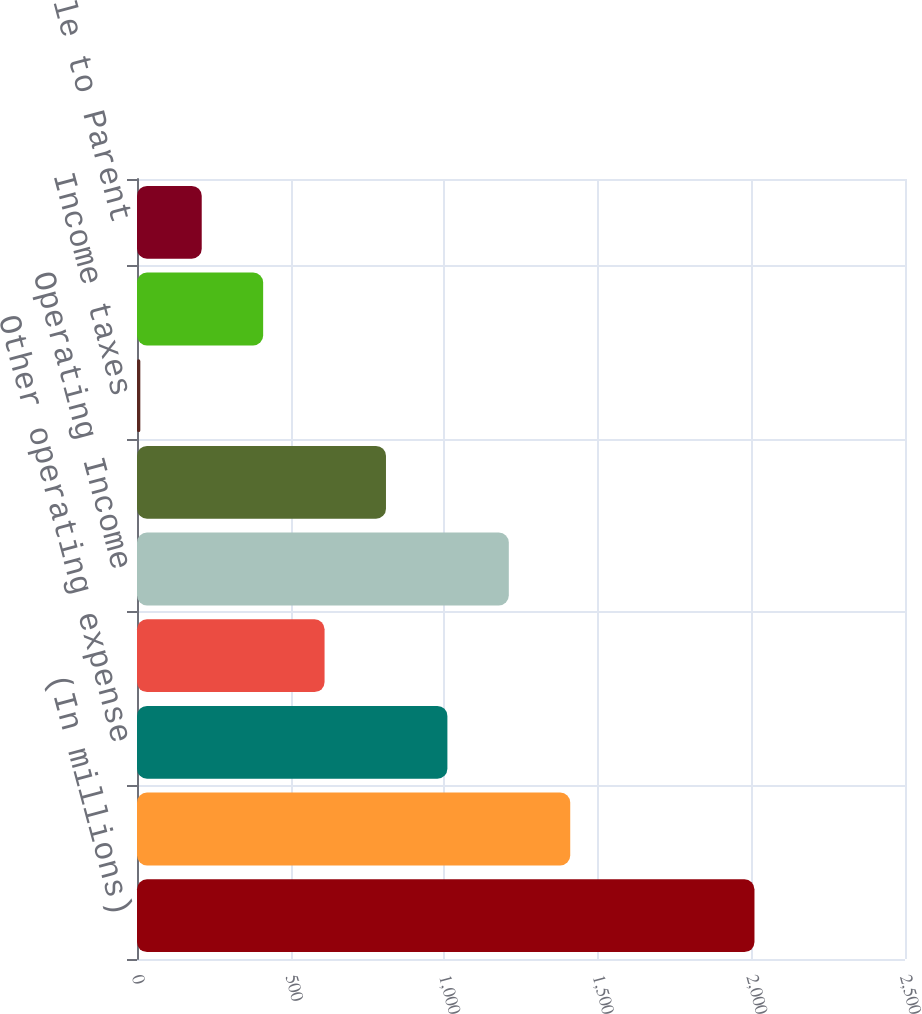Convert chart to OTSL. <chart><loc_0><loc_0><loc_500><loc_500><bar_chart><fcel>(In millions)<fcel>Revenues<fcel>Other operating expense<fcel>Provision for depreciation<fcel>Operating Income<fcel>Income before income taxes<fcel>Income taxes<fcel>Net Income<fcel>Earnings available to Parent<nl><fcel>2010<fcel>1410.24<fcel>1010.4<fcel>610.56<fcel>1210.32<fcel>810.48<fcel>10.8<fcel>410.64<fcel>210.72<nl></chart> 